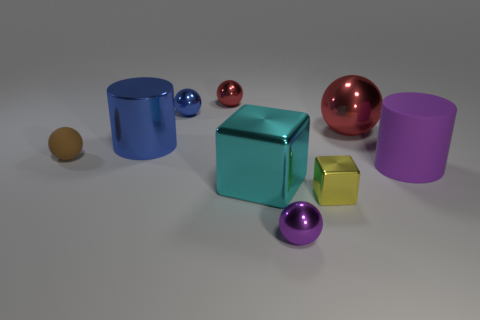Subtract all gray cylinders. Subtract all green balls. How many cylinders are left? 2 Subtract all blocks. How many objects are left? 7 Add 3 big brown metallic cylinders. How many big brown metallic cylinders exist? 3 Subtract 0 red cylinders. How many objects are left? 9 Subtract all small brown metal cylinders. Subtract all tiny red spheres. How many objects are left? 8 Add 7 purple objects. How many purple objects are left? 9 